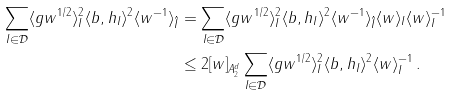Convert formula to latex. <formula><loc_0><loc_0><loc_500><loc_500>\sum _ { I \in \mathcal { D } } \langle g w ^ { 1 / 2 } \rangle _ { I } ^ { 2 } \langle b , h _ { I } \rangle ^ { 2 } \langle w ^ { - 1 } \rangle _ { \hat { I } } & = \sum _ { I \in \mathcal { D } } \langle g w ^ { 1 / 2 } \rangle _ { I } ^ { 2 } \langle b , h _ { I } \rangle ^ { 2 } \langle w ^ { - 1 } \rangle _ { \hat { I } } \langle w \rangle _ { I } \langle w \rangle _ { I } ^ { - 1 } \\ & \leq 2 [ w ] _ { A ^ { d } _ { 2 } } \sum _ { I \in \mathcal { D } } \langle g w ^ { 1 / 2 } \rangle _ { I } ^ { 2 } \langle b , h _ { I } \rangle ^ { 2 } \langle w \rangle _ { I } ^ { - 1 } \, .</formula> 